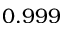<formula> <loc_0><loc_0><loc_500><loc_500>0 . 9 9 9</formula> 